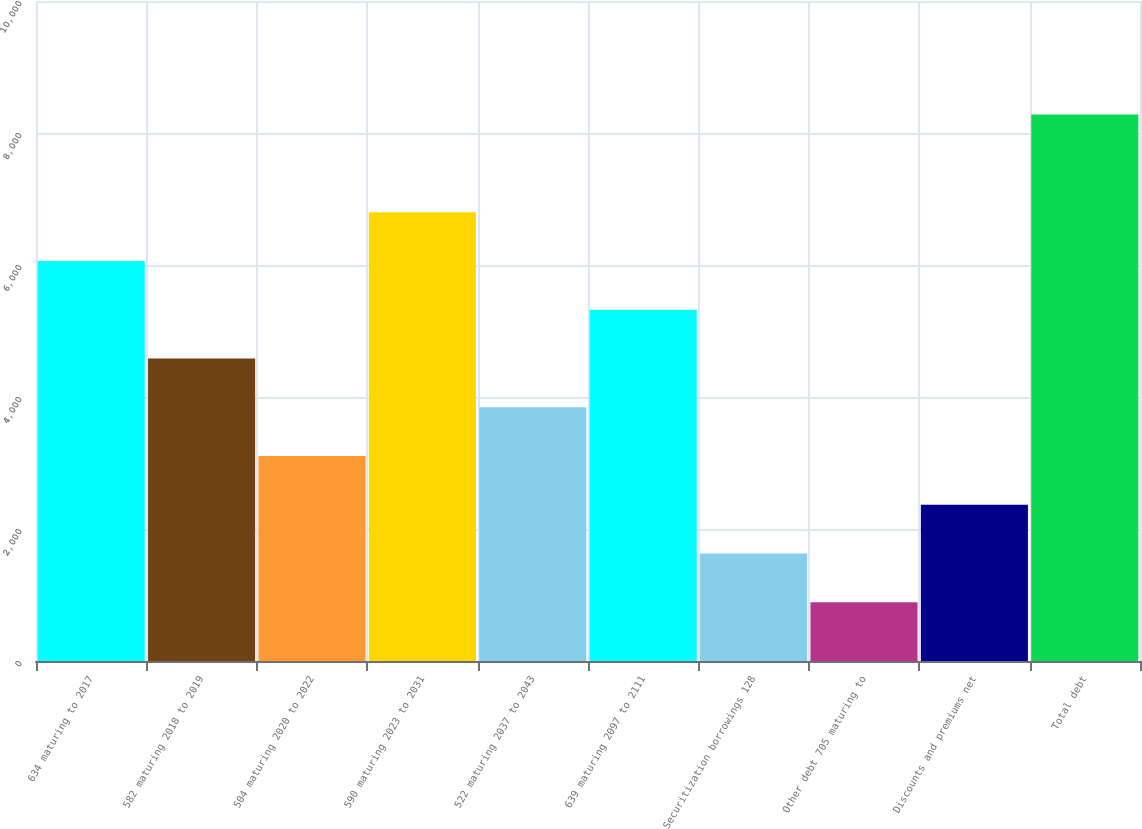Convert chart to OTSL. <chart><loc_0><loc_0><loc_500><loc_500><bar_chart><fcel>634 maturing to 2017<fcel>582 maturing 2018 to 2019<fcel>504 maturing 2020 to 2022<fcel>590 maturing 2023 to 2031<fcel>522 maturing 2037 to 2043<fcel>639 maturing 2097 to 2111<fcel>Securitization borrowings 128<fcel>Other debt 705 maturing to<fcel>Discounts and premiums net<fcel>Total debt<nl><fcel>6062<fcel>4584<fcel>3106<fcel>6801<fcel>3845<fcel>5323<fcel>1628<fcel>889<fcel>2367<fcel>8279<nl></chart> 